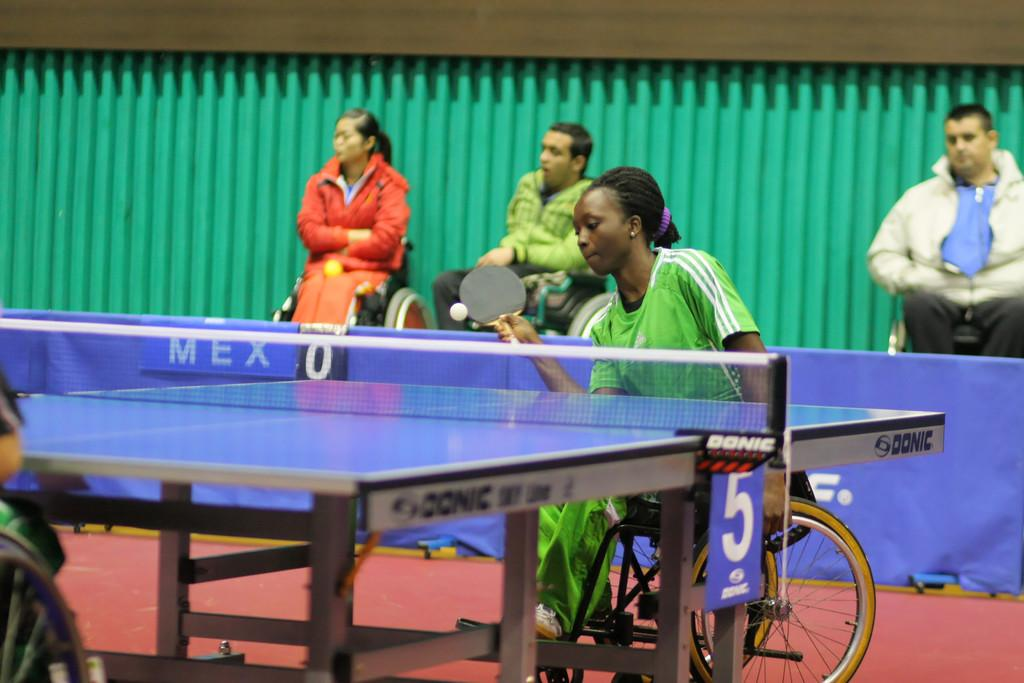Who is the main subject in the image? There is a girl in the image. What is the girl doing in the image? The girl is playing table tennis. What is the girl sitting on in the image? The girl is sitting on a chair. What else can be seen in the image related to table tennis? There is a table tennis table in the image. Are there any other people in the image? Yes, there are other persons sitting on chairs in the image. What is the girl's reaction to the alley in the image? There is no alley present in the image, so it is not possible to determine the girl's reaction to it. 